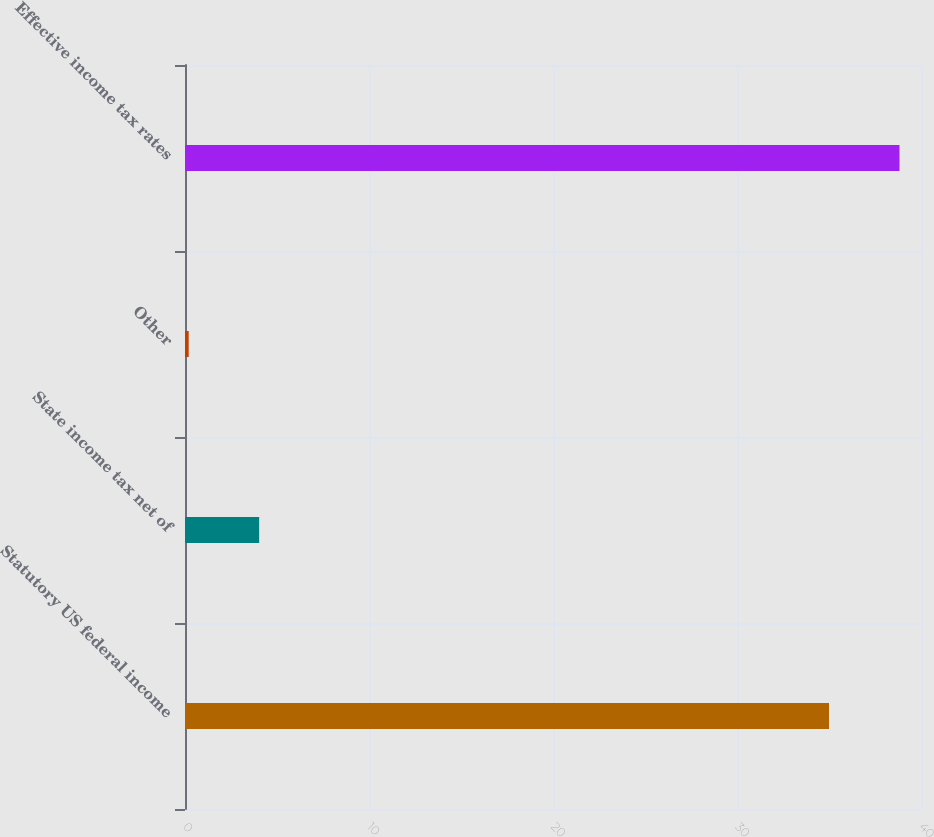<chart> <loc_0><loc_0><loc_500><loc_500><bar_chart><fcel>Statutory US federal income<fcel>State income tax net of<fcel>Other<fcel>Effective income tax rates<nl><fcel>35<fcel>4.03<fcel>0.2<fcel>38.83<nl></chart> 